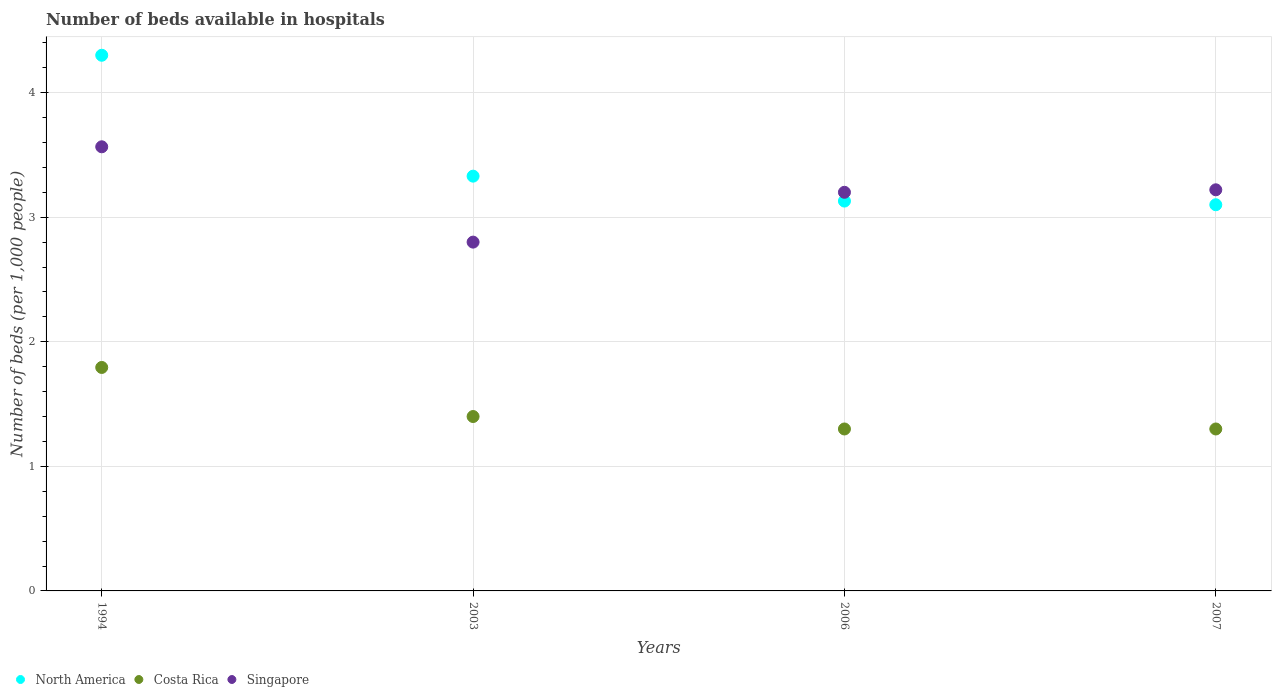How many different coloured dotlines are there?
Your answer should be compact. 3. Is the number of dotlines equal to the number of legend labels?
Keep it short and to the point. Yes. What is the number of beds in the hospiatls of in Costa Rica in 2003?
Make the answer very short. 1.4. Across all years, what is the maximum number of beds in the hospiatls of in North America?
Offer a very short reply. 4.3. In which year was the number of beds in the hospiatls of in Singapore minimum?
Your answer should be very brief. 2003. What is the total number of beds in the hospiatls of in North America in the graph?
Offer a terse response. 13.86. What is the difference between the number of beds in the hospiatls of in Singapore in 2003 and that in 2006?
Your response must be concise. -0.4. What is the difference between the number of beds in the hospiatls of in Costa Rica in 1994 and the number of beds in the hospiatls of in North America in 2007?
Offer a terse response. -1.31. What is the average number of beds in the hospiatls of in Costa Rica per year?
Offer a very short reply. 1.45. In the year 1994, what is the difference between the number of beds in the hospiatls of in North America and number of beds in the hospiatls of in Singapore?
Offer a very short reply. 0.73. In how many years, is the number of beds in the hospiatls of in North America greater than 1?
Provide a succinct answer. 4. What is the ratio of the number of beds in the hospiatls of in North America in 1994 to that in 2007?
Ensure brevity in your answer.  1.39. What is the difference between the highest and the second highest number of beds in the hospiatls of in Singapore?
Offer a very short reply. 0.35. What is the difference between the highest and the lowest number of beds in the hospiatls of in Costa Rica?
Give a very brief answer. 0.49. Is the sum of the number of beds in the hospiatls of in Costa Rica in 2003 and 2007 greater than the maximum number of beds in the hospiatls of in North America across all years?
Your answer should be very brief. No. Is it the case that in every year, the sum of the number of beds in the hospiatls of in Singapore and number of beds in the hospiatls of in North America  is greater than the number of beds in the hospiatls of in Costa Rica?
Keep it short and to the point. Yes. Is the number of beds in the hospiatls of in Costa Rica strictly less than the number of beds in the hospiatls of in North America over the years?
Provide a succinct answer. Yes. How many dotlines are there?
Offer a terse response. 3. What is the difference between two consecutive major ticks on the Y-axis?
Your answer should be compact. 1. Does the graph contain grids?
Give a very brief answer. Yes. What is the title of the graph?
Make the answer very short. Number of beds available in hospitals. Does "Liberia" appear as one of the legend labels in the graph?
Provide a short and direct response. No. What is the label or title of the Y-axis?
Ensure brevity in your answer.  Number of beds (per 1,0 people). What is the Number of beds (per 1,000 people) of North America in 1994?
Offer a terse response. 4.3. What is the Number of beds (per 1,000 people) of Costa Rica in 1994?
Make the answer very short. 1.79. What is the Number of beds (per 1,000 people) in Singapore in 1994?
Your answer should be compact. 3.57. What is the Number of beds (per 1,000 people) in North America in 2003?
Give a very brief answer. 3.33. What is the Number of beds (per 1,000 people) in Costa Rica in 2003?
Provide a succinct answer. 1.4. What is the Number of beds (per 1,000 people) of North America in 2006?
Your answer should be very brief. 3.13. What is the Number of beds (per 1,000 people) in Costa Rica in 2006?
Provide a succinct answer. 1.3. What is the Number of beds (per 1,000 people) in Costa Rica in 2007?
Ensure brevity in your answer.  1.3. What is the Number of beds (per 1,000 people) of Singapore in 2007?
Offer a very short reply. 3.22. Across all years, what is the maximum Number of beds (per 1,000 people) of North America?
Offer a terse response. 4.3. Across all years, what is the maximum Number of beds (per 1,000 people) of Costa Rica?
Keep it short and to the point. 1.79. Across all years, what is the maximum Number of beds (per 1,000 people) in Singapore?
Make the answer very short. 3.57. What is the total Number of beds (per 1,000 people) in North America in the graph?
Provide a short and direct response. 13.86. What is the total Number of beds (per 1,000 people) of Costa Rica in the graph?
Your answer should be compact. 5.79. What is the total Number of beds (per 1,000 people) of Singapore in the graph?
Ensure brevity in your answer.  12.79. What is the difference between the Number of beds (per 1,000 people) in North America in 1994 and that in 2003?
Make the answer very short. 0.97. What is the difference between the Number of beds (per 1,000 people) of Costa Rica in 1994 and that in 2003?
Give a very brief answer. 0.39. What is the difference between the Number of beds (per 1,000 people) in Singapore in 1994 and that in 2003?
Ensure brevity in your answer.  0.77. What is the difference between the Number of beds (per 1,000 people) in North America in 1994 and that in 2006?
Keep it short and to the point. 1.17. What is the difference between the Number of beds (per 1,000 people) in Costa Rica in 1994 and that in 2006?
Offer a very short reply. 0.49. What is the difference between the Number of beds (per 1,000 people) of Singapore in 1994 and that in 2006?
Provide a succinct answer. 0.37. What is the difference between the Number of beds (per 1,000 people) of Costa Rica in 1994 and that in 2007?
Provide a succinct answer. 0.49. What is the difference between the Number of beds (per 1,000 people) in Singapore in 1994 and that in 2007?
Your response must be concise. 0.35. What is the difference between the Number of beds (per 1,000 people) of North America in 2003 and that in 2007?
Provide a short and direct response. 0.23. What is the difference between the Number of beds (per 1,000 people) of Costa Rica in 2003 and that in 2007?
Give a very brief answer. 0.1. What is the difference between the Number of beds (per 1,000 people) of Singapore in 2003 and that in 2007?
Provide a short and direct response. -0.42. What is the difference between the Number of beds (per 1,000 people) in North America in 2006 and that in 2007?
Your answer should be compact. 0.03. What is the difference between the Number of beds (per 1,000 people) of Costa Rica in 2006 and that in 2007?
Make the answer very short. 0. What is the difference between the Number of beds (per 1,000 people) of Singapore in 2006 and that in 2007?
Offer a very short reply. -0.02. What is the difference between the Number of beds (per 1,000 people) of North America in 1994 and the Number of beds (per 1,000 people) of Costa Rica in 2003?
Your answer should be very brief. 2.9. What is the difference between the Number of beds (per 1,000 people) in Costa Rica in 1994 and the Number of beds (per 1,000 people) in Singapore in 2003?
Ensure brevity in your answer.  -1.01. What is the difference between the Number of beds (per 1,000 people) of Costa Rica in 1994 and the Number of beds (per 1,000 people) of Singapore in 2006?
Make the answer very short. -1.41. What is the difference between the Number of beds (per 1,000 people) of North America in 1994 and the Number of beds (per 1,000 people) of Costa Rica in 2007?
Provide a succinct answer. 3. What is the difference between the Number of beds (per 1,000 people) of North America in 1994 and the Number of beds (per 1,000 people) of Singapore in 2007?
Offer a very short reply. 1.08. What is the difference between the Number of beds (per 1,000 people) in Costa Rica in 1994 and the Number of beds (per 1,000 people) in Singapore in 2007?
Provide a short and direct response. -1.43. What is the difference between the Number of beds (per 1,000 people) in North America in 2003 and the Number of beds (per 1,000 people) in Costa Rica in 2006?
Give a very brief answer. 2.03. What is the difference between the Number of beds (per 1,000 people) in North America in 2003 and the Number of beds (per 1,000 people) in Singapore in 2006?
Offer a very short reply. 0.13. What is the difference between the Number of beds (per 1,000 people) in Costa Rica in 2003 and the Number of beds (per 1,000 people) in Singapore in 2006?
Give a very brief answer. -1.8. What is the difference between the Number of beds (per 1,000 people) of North America in 2003 and the Number of beds (per 1,000 people) of Costa Rica in 2007?
Ensure brevity in your answer.  2.03. What is the difference between the Number of beds (per 1,000 people) in North America in 2003 and the Number of beds (per 1,000 people) in Singapore in 2007?
Provide a short and direct response. 0.11. What is the difference between the Number of beds (per 1,000 people) of Costa Rica in 2003 and the Number of beds (per 1,000 people) of Singapore in 2007?
Provide a short and direct response. -1.82. What is the difference between the Number of beds (per 1,000 people) in North America in 2006 and the Number of beds (per 1,000 people) in Costa Rica in 2007?
Keep it short and to the point. 1.83. What is the difference between the Number of beds (per 1,000 people) of North America in 2006 and the Number of beds (per 1,000 people) of Singapore in 2007?
Ensure brevity in your answer.  -0.09. What is the difference between the Number of beds (per 1,000 people) of Costa Rica in 2006 and the Number of beds (per 1,000 people) of Singapore in 2007?
Offer a terse response. -1.92. What is the average Number of beds (per 1,000 people) in North America per year?
Your response must be concise. 3.46. What is the average Number of beds (per 1,000 people) of Costa Rica per year?
Offer a very short reply. 1.45. What is the average Number of beds (per 1,000 people) in Singapore per year?
Offer a very short reply. 3.2. In the year 1994, what is the difference between the Number of beds (per 1,000 people) in North America and Number of beds (per 1,000 people) in Costa Rica?
Offer a very short reply. 2.51. In the year 1994, what is the difference between the Number of beds (per 1,000 people) of North America and Number of beds (per 1,000 people) of Singapore?
Your answer should be very brief. 0.73. In the year 1994, what is the difference between the Number of beds (per 1,000 people) in Costa Rica and Number of beds (per 1,000 people) in Singapore?
Offer a very short reply. -1.77. In the year 2003, what is the difference between the Number of beds (per 1,000 people) of North America and Number of beds (per 1,000 people) of Costa Rica?
Your answer should be compact. 1.93. In the year 2003, what is the difference between the Number of beds (per 1,000 people) of North America and Number of beds (per 1,000 people) of Singapore?
Your answer should be very brief. 0.53. In the year 2006, what is the difference between the Number of beds (per 1,000 people) of North America and Number of beds (per 1,000 people) of Costa Rica?
Your answer should be very brief. 1.83. In the year 2006, what is the difference between the Number of beds (per 1,000 people) of North America and Number of beds (per 1,000 people) of Singapore?
Provide a succinct answer. -0.07. In the year 2006, what is the difference between the Number of beds (per 1,000 people) in Costa Rica and Number of beds (per 1,000 people) in Singapore?
Your response must be concise. -1.9. In the year 2007, what is the difference between the Number of beds (per 1,000 people) in North America and Number of beds (per 1,000 people) in Singapore?
Make the answer very short. -0.12. In the year 2007, what is the difference between the Number of beds (per 1,000 people) of Costa Rica and Number of beds (per 1,000 people) of Singapore?
Offer a terse response. -1.92. What is the ratio of the Number of beds (per 1,000 people) in North America in 1994 to that in 2003?
Provide a short and direct response. 1.29. What is the ratio of the Number of beds (per 1,000 people) in Costa Rica in 1994 to that in 2003?
Your answer should be very brief. 1.28. What is the ratio of the Number of beds (per 1,000 people) in Singapore in 1994 to that in 2003?
Offer a very short reply. 1.27. What is the ratio of the Number of beds (per 1,000 people) in North America in 1994 to that in 2006?
Offer a very short reply. 1.37. What is the ratio of the Number of beds (per 1,000 people) in Costa Rica in 1994 to that in 2006?
Keep it short and to the point. 1.38. What is the ratio of the Number of beds (per 1,000 people) in Singapore in 1994 to that in 2006?
Provide a short and direct response. 1.11. What is the ratio of the Number of beds (per 1,000 people) of North America in 1994 to that in 2007?
Ensure brevity in your answer.  1.39. What is the ratio of the Number of beds (per 1,000 people) in Costa Rica in 1994 to that in 2007?
Offer a terse response. 1.38. What is the ratio of the Number of beds (per 1,000 people) in Singapore in 1994 to that in 2007?
Your answer should be very brief. 1.11. What is the ratio of the Number of beds (per 1,000 people) in North America in 2003 to that in 2006?
Your response must be concise. 1.06. What is the ratio of the Number of beds (per 1,000 people) of Costa Rica in 2003 to that in 2006?
Your answer should be very brief. 1.08. What is the ratio of the Number of beds (per 1,000 people) of Singapore in 2003 to that in 2006?
Give a very brief answer. 0.88. What is the ratio of the Number of beds (per 1,000 people) in North America in 2003 to that in 2007?
Your answer should be very brief. 1.07. What is the ratio of the Number of beds (per 1,000 people) in Singapore in 2003 to that in 2007?
Offer a very short reply. 0.87. What is the ratio of the Number of beds (per 1,000 people) in North America in 2006 to that in 2007?
Provide a succinct answer. 1.01. What is the ratio of the Number of beds (per 1,000 people) of Costa Rica in 2006 to that in 2007?
Offer a very short reply. 1. What is the ratio of the Number of beds (per 1,000 people) of Singapore in 2006 to that in 2007?
Provide a succinct answer. 0.99. What is the difference between the highest and the second highest Number of beds (per 1,000 people) in North America?
Make the answer very short. 0.97. What is the difference between the highest and the second highest Number of beds (per 1,000 people) of Costa Rica?
Your answer should be compact. 0.39. What is the difference between the highest and the second highest Number of beds (per 1,000 people) of Singapore?
Your answer should be very brief. 0.35. What is the difference between the highest and the lowest Number of beds (per 1,000 people) of Costa Rica?
Provide a short and direct response. 0.49. What is the difference between the highest and the lowest Number of beds (per 1,000 people) in Singapore?
Make the answer very short. 0.77. 